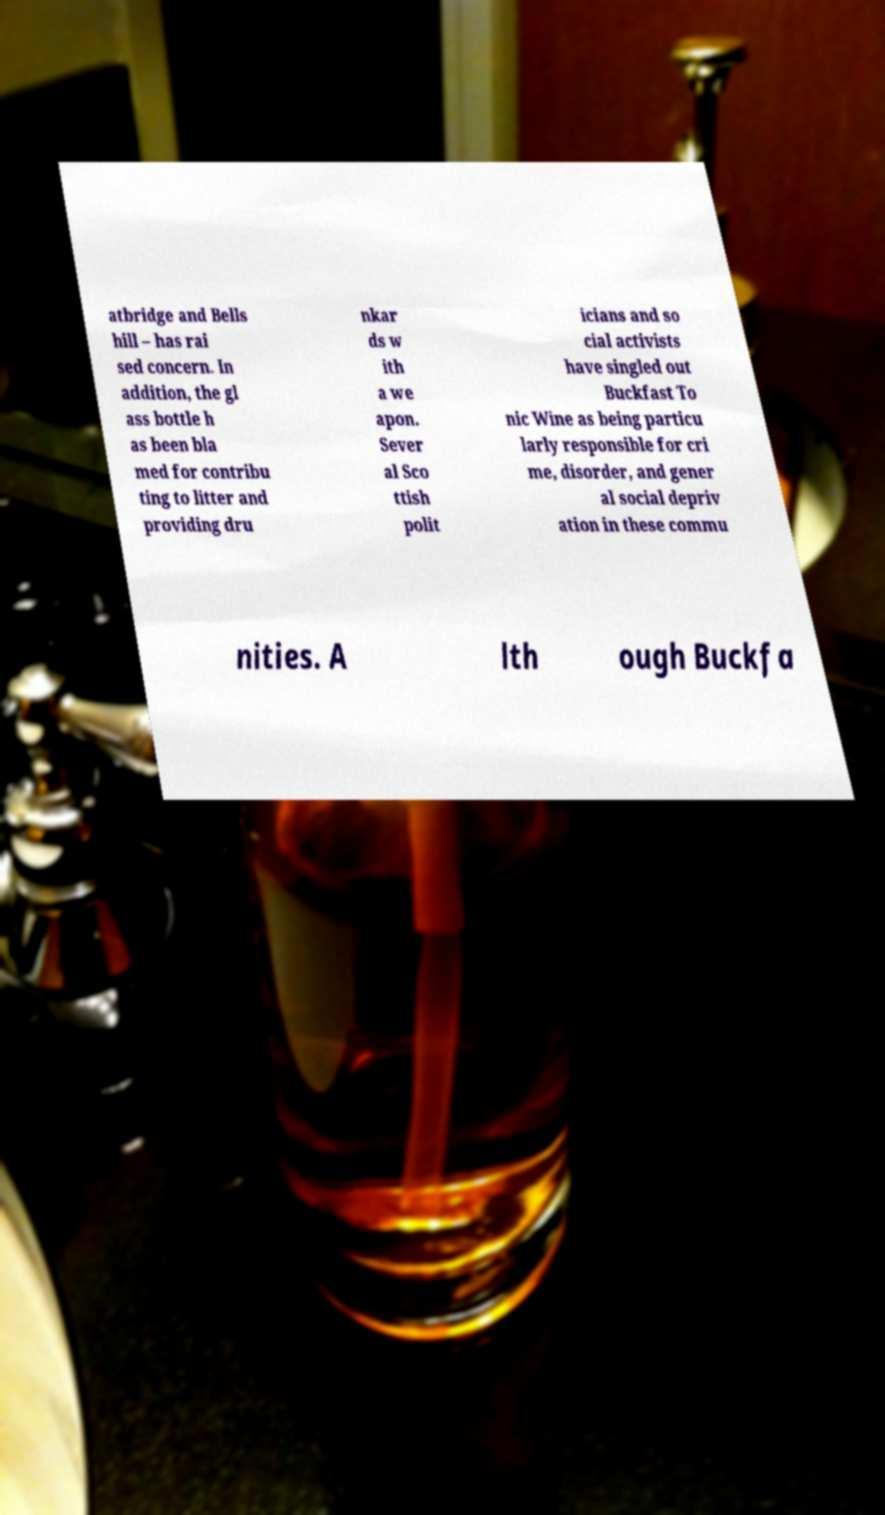There's text embedded in this image that I need extracted. Can you transcribe it verbatim? atbridge and Bells hill – has rai sed concern. In addition, the gl ass bottle h as been bla med for contribu ting to litter and providing dru nkar ds w ith a we apon. Sever al Sco ttish polit icians and so cial activists have singled out Buckfast To nic Wine as being particu larly responsible for cri me, disorder, and gener al social depriv ation in these commu nities. A lth ough Buckfa 